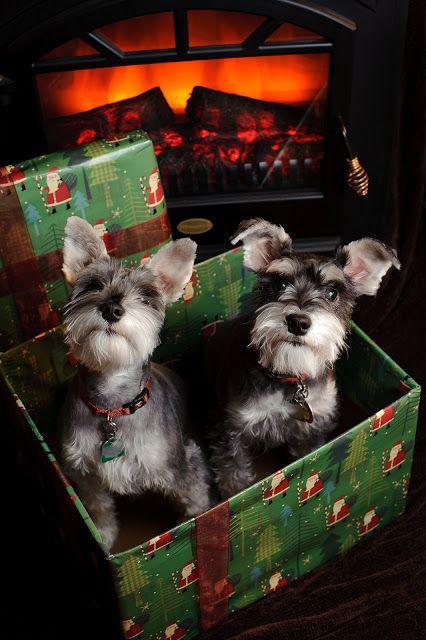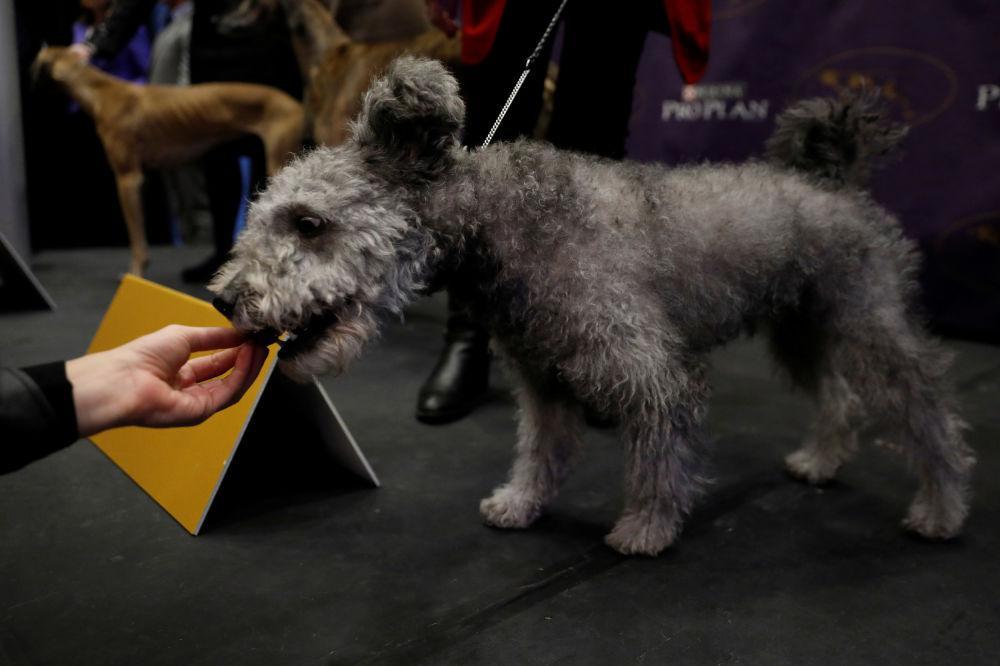The first image is the image on the left, the second image is the image on the right. For the images shown, is this caption "One dog has its mouth open." true? Answer yes or no. Yes. The first image is the image on the left, the second image is the image on the right. Given the left and right images, does the statement "At least one schnauzer is sitting upright and wearing a collar with a dangling tag, but no other attire." hold true? Answer yes or no. Yes. 